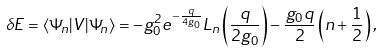<formula> <loc_0><loc_0><loc_500><loc_500>\delta E = \langle \Psi _ { n } | V | \Psi _ { n } \rangle = - g _ { 0 } ^ { 2 } e ^ { - \frac { q } { 4 g _ { 0 } } } L _ { n } \left ( \frac { q } { 2 g _ { 0 } } \right ) - \frac { g _ { 0 } q } { 2 } \left ( n + \frac { 1 } { 2 } \right ) ,</formula> 